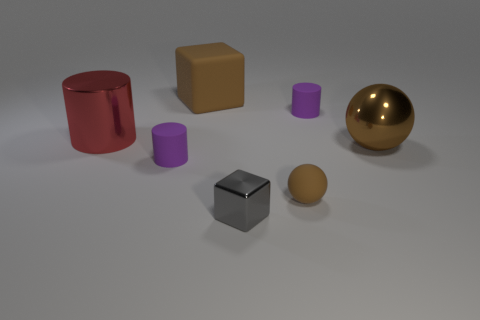There is a object to the left of the purple cylinder that is to the left of the tiny purple rubber cylinder right of the gray metal block; how big is it?
Give a very brief answer. Large. How many red things are large cylinders or small rubber objects?
Ensure brevity in your answer.  1. There is a brown matte thing that is in front of the cube behind the small gray block; what shape is it?
Keep it short and to the point. Sphere. There is a brown rubber object in front of the big brown ball; does it have the same size as the metal thing that is in front of the tiny brown object?
Ensure brevity in your answer.  Yes. Are there any small yellow blocks that have the same material as the tiny gray cube?
Offer a very short reply. No. There is a shiny sphere that is the same color as the large cube; what is its size?
Make the answer very short. Large. Are there any small rubber spheres that are to the left of the tiny cylinder that is to the right of the purple rubber thing on the left side of the tiny gray thing?
Ensure brevity in your answer.  Yes. There is a tiny rubber ball; are there any purple cylinders left of it?
Your answer should be compact. Yes. There is a matte cylinder to the left of the gray metallic object; what number of brown metal balls are in front of it?
Ensure brevity in your answer.  0. Is the size of the gray object the same as the purple rubber object in front of the large brown metal thing?
Your answer should be very brief. Yes. 